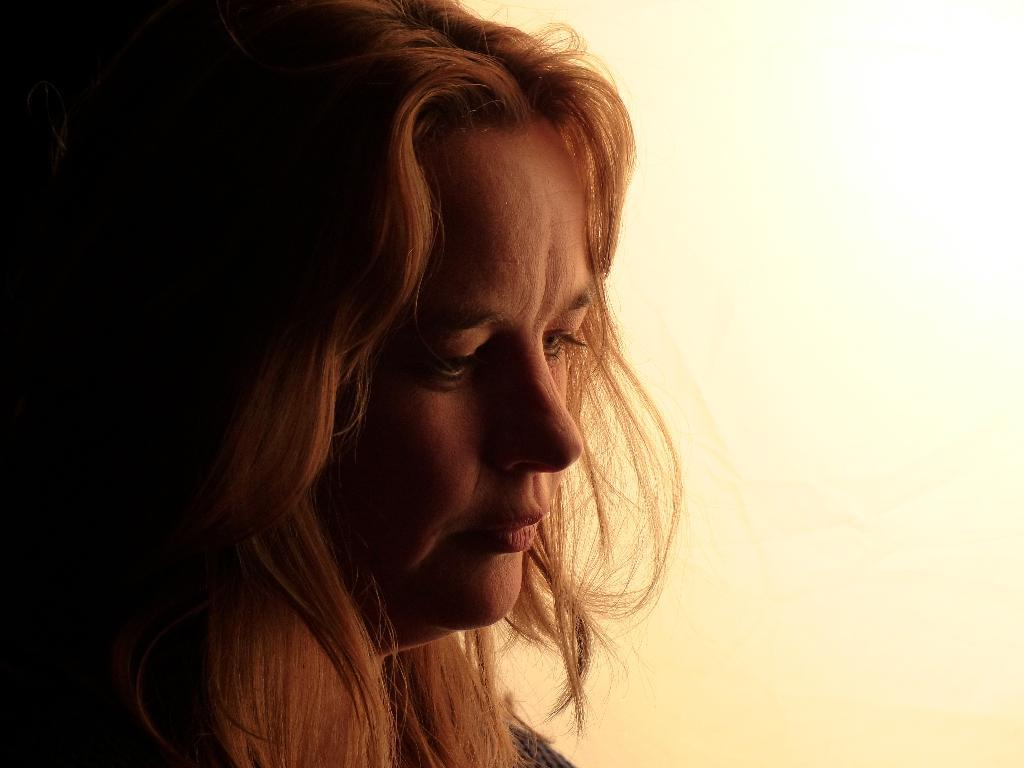Who is the main subject in the image? There is a woman in the image. What is a notable feature of the woman's appearance? The woman has blond hair. On which side of the image is the woman located? The woman is on the left side of the image. What can be seen behind the woman in the image? There is a wall behind the woman. What type of thing is the beggar holding in the image? There is no beggar present in the image, and therefore no such object can be observed. 